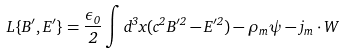Convert formula to latex. <formula><loc_0><loc_0><loc_500><loc_500>L \{ B ^ { \prime } , E ^ { \prime } \} = \frac { \epsilon _ { 0 } } { 2 } \int d ^ { 3 } x ( c ^ { 2 } B ^ { \prime 2 } - E ^ { \prime 2 } ) - \rho _ { m } \psi - j _ { m } \cdot W</formula> 